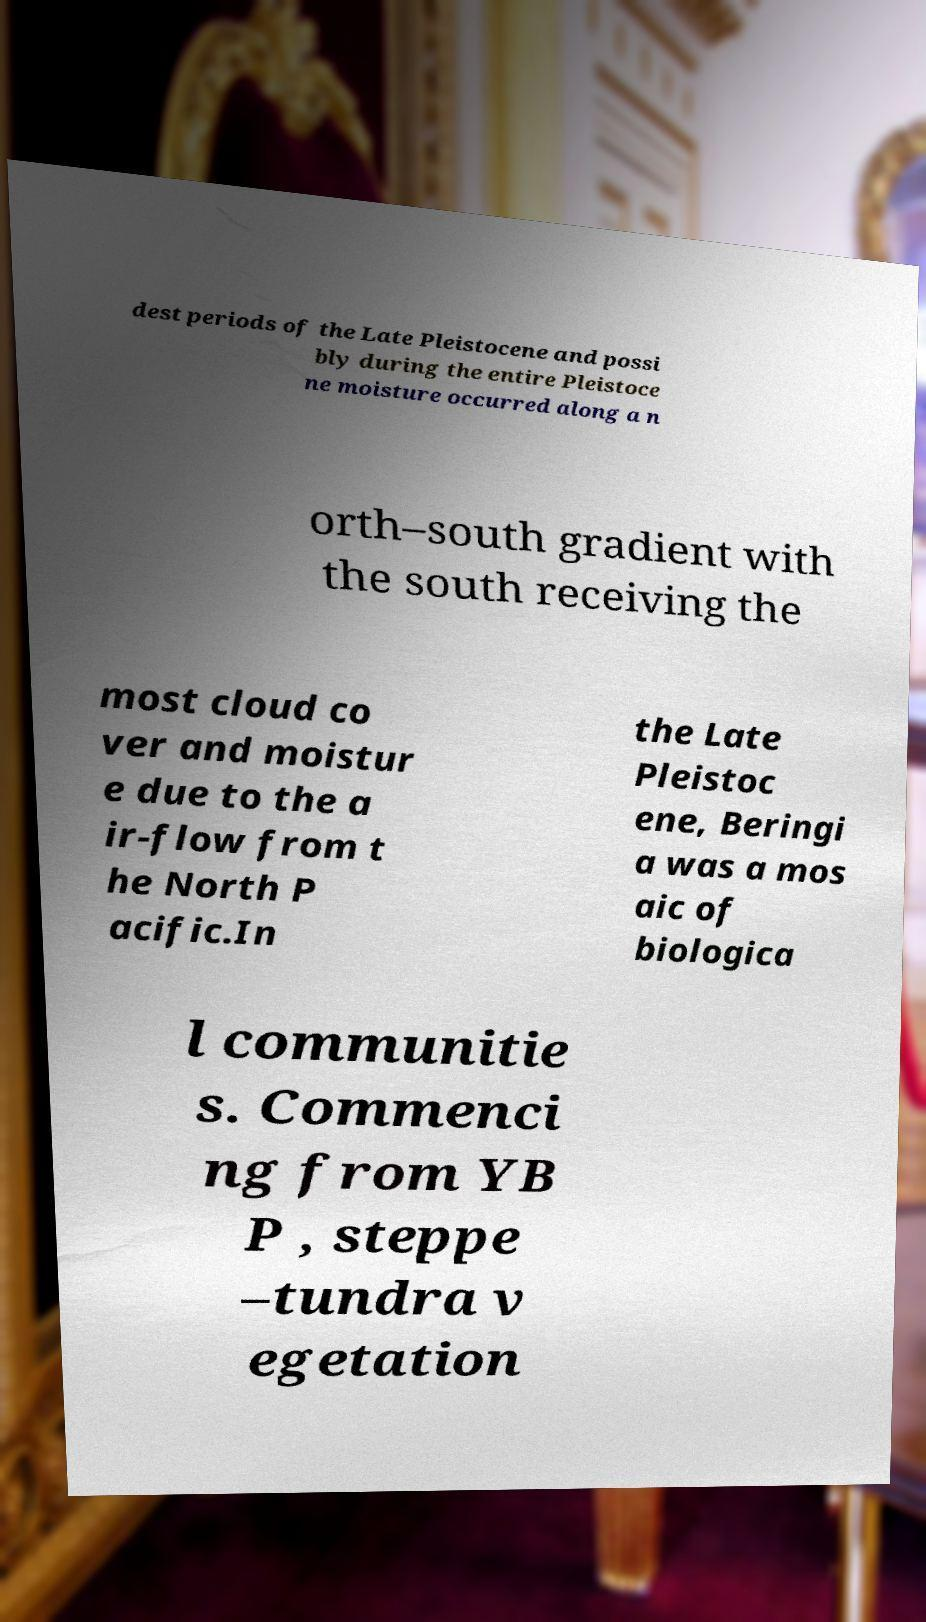Could you assist in decoding the text presented in this image and type it out clearly? dest periods of the Late Pleistocene and possi bly during the entire Pleistoce ne moisture occurred along a n orth–south gradient with the south receiving the most cloud co ver and moistur e due to the a ir-flow from t he North P acific.In the Late Pleistoc ene, Beringi a was a mos aic of biologica l communitie s. Commenci ng from YB P , steppe –tundra v egetation 